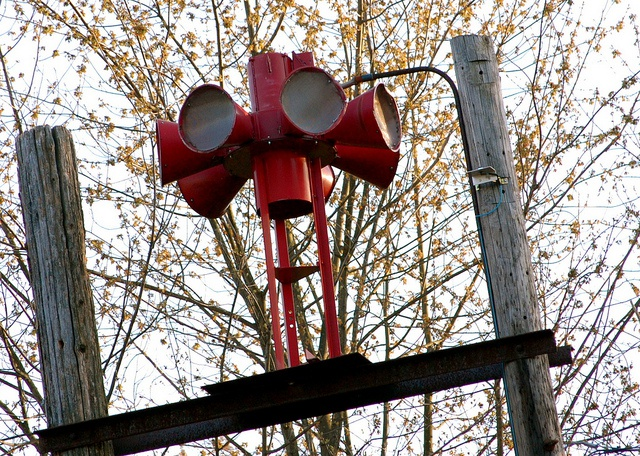Describe the objects in this image and their specific colors. I can see a traffic light in purple, black, maroon, gray, and brown tones in this image. 